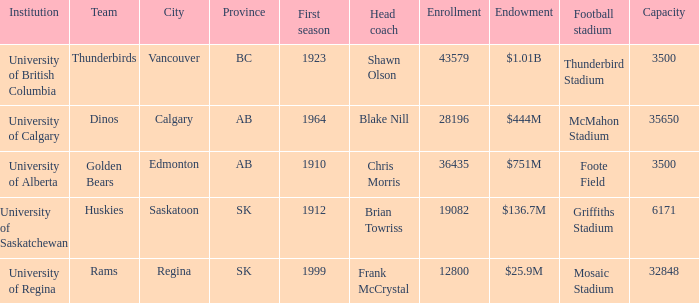What is the enrollment for Foote Field? 36435.0. 